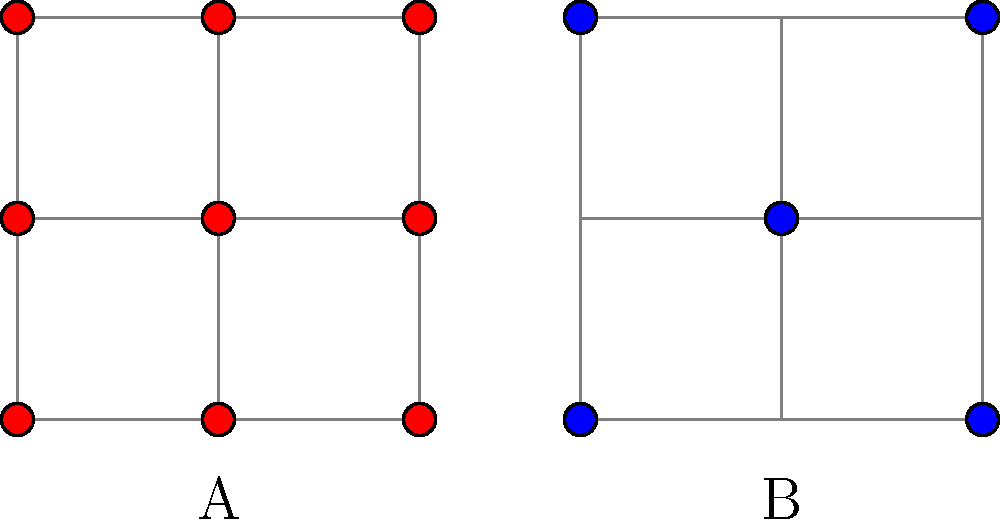As an engineering student interested in materials science, identify the crystal structures represented by the 2D lattice diagrams A and B. Which structure is more commonly found in metals, and why? Let's analyze the crystal structures step-by-step:

1. Structure A:
   - Atoms are located at all corners and the center of each side of the unit cell.
   - This represents a 2D projection of a Face-Centered Cubic (FCC) structure.

2. Structure B:
   - Atoms are located at all corners and the center of the unit cell.
   - This represents a 2D projection of a Body-Centered Cubic (BCC) structure.

3. Comparison of structures in metals:
   - FCC (Structure A) is more commonly found in metals.
   - Reasons for FCC prevalence in metals:
     a) Higher packing efficiency: FCC has a packing factor of 0.74, while BCC has 0.68.
     b) More slip systems: FCC has 12 slip systems, allowing for easier plastic deformation.
     c) Better ductility: The higher number of slip systems in FCC promotes better ductility.

4. Examples of FCC metals:
   - Aluminum, copper, gold, silver, platinum, and nickel.

5. Examples of BCC metals:
   - Iron (at room temperature), chromium, tungsten, and molybdenum.

The FCC structure's higher prevalence in metals is due to its superior packing efficiency and mechanical properties, which are often desirable in engineering applications.
Answer: A: FCC, B: BCC. FCC is more common in metals due to higher packing efficiency and more slip systems. 